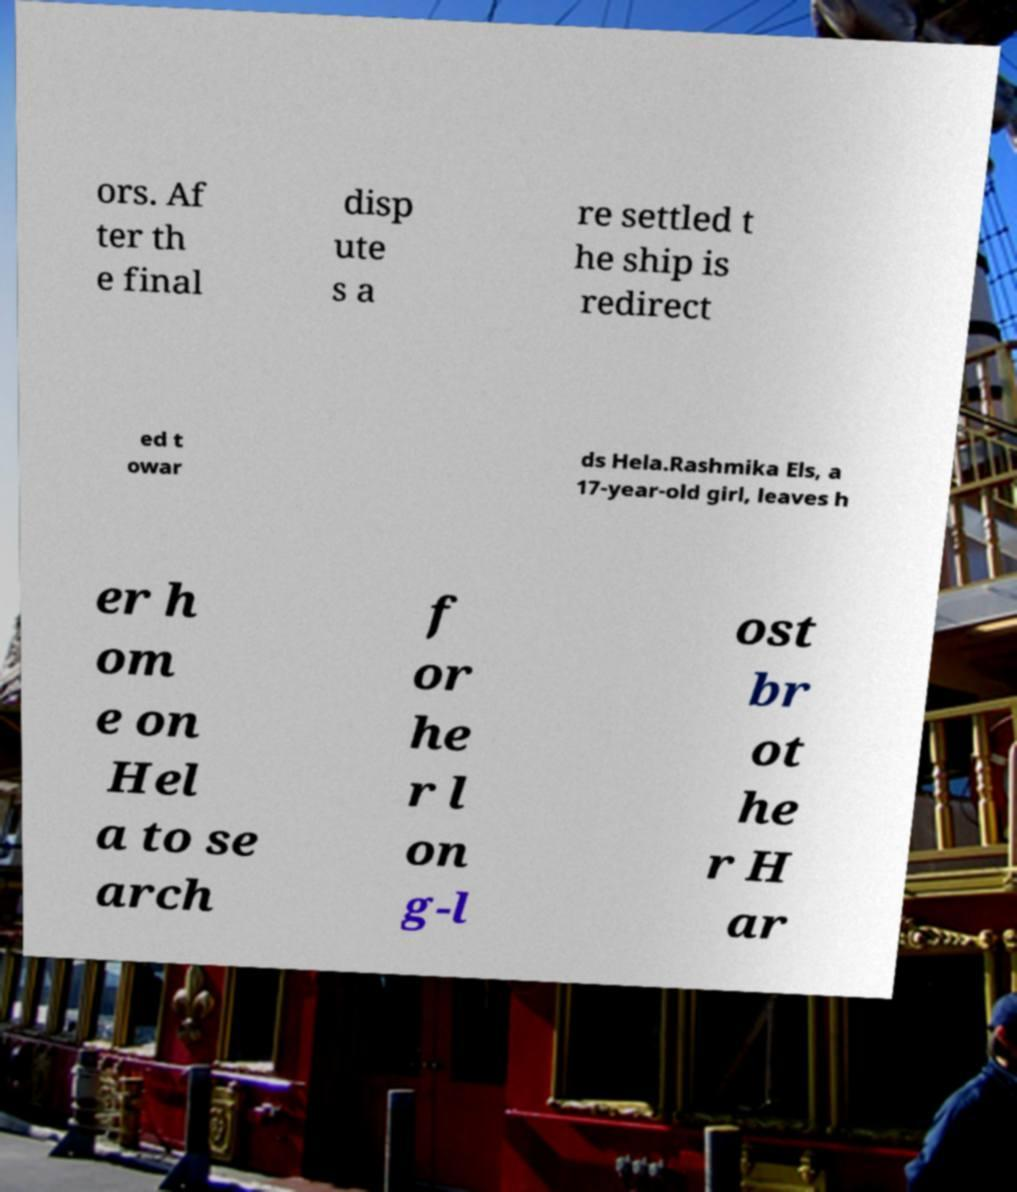For documentation purposes, I need the text within this image transcribed. Could you provide that? ors. Af ter th e final disp ute s a re settled t he ship is redirect ed t owar ds Hela.Rashmika Els, a 17-year-old girl, leaves h er h om e on Hel a to se arch f or he r l on g-l ost br ot he r H ar 